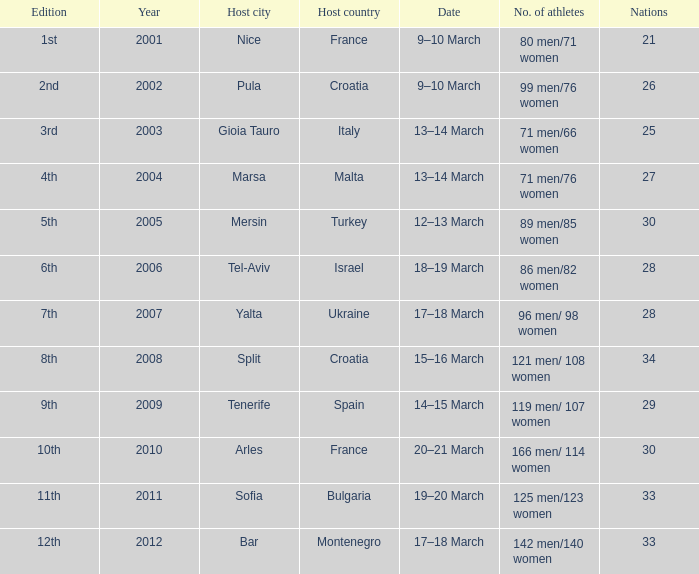What was the number of athletes for the 7th edition? 96 men/ 98 women. 